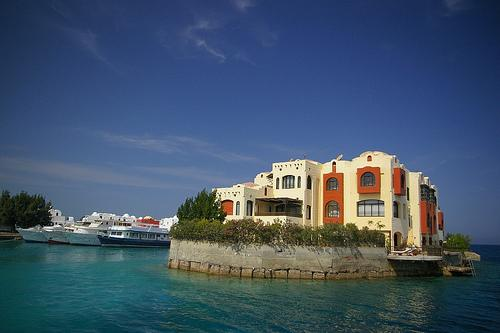What is the house near? water 